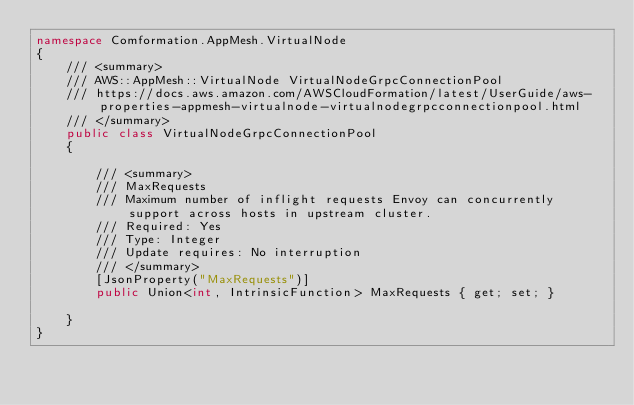<code> <loc_0><loc_0><loc_500><loc_500><_C#_>namespace Comformation.AppMesh.VirtualNode
{
    /// <summary>
    /// AWS::AppMesh::VirtualNode VirtualNodeGrpcConnectionPool
    /// https://docs.aws.amazon.com/AWSCloudFormation/latest/UserGuide/aws-properties-appmesh-virtualnode-virtualnodegrpcconnectionpool.html
    /// </summary>
    public class VirtualNodeGrpcConnectionPool
    {

        /// <summary>
        /// MaxRequests
        /// Maximum number of inflight requests Envoy can concurrently support across hosts in upstream cluster.
        /// Required: Yes
        /// Type: Integer
        /// Update requires: No interruption
        /// </summary>
        [JsonProperty("MaxRequests")]
        public Union<int, IntrinsicFunction> MaxRequests { get; set; }

    }
}
</code> 